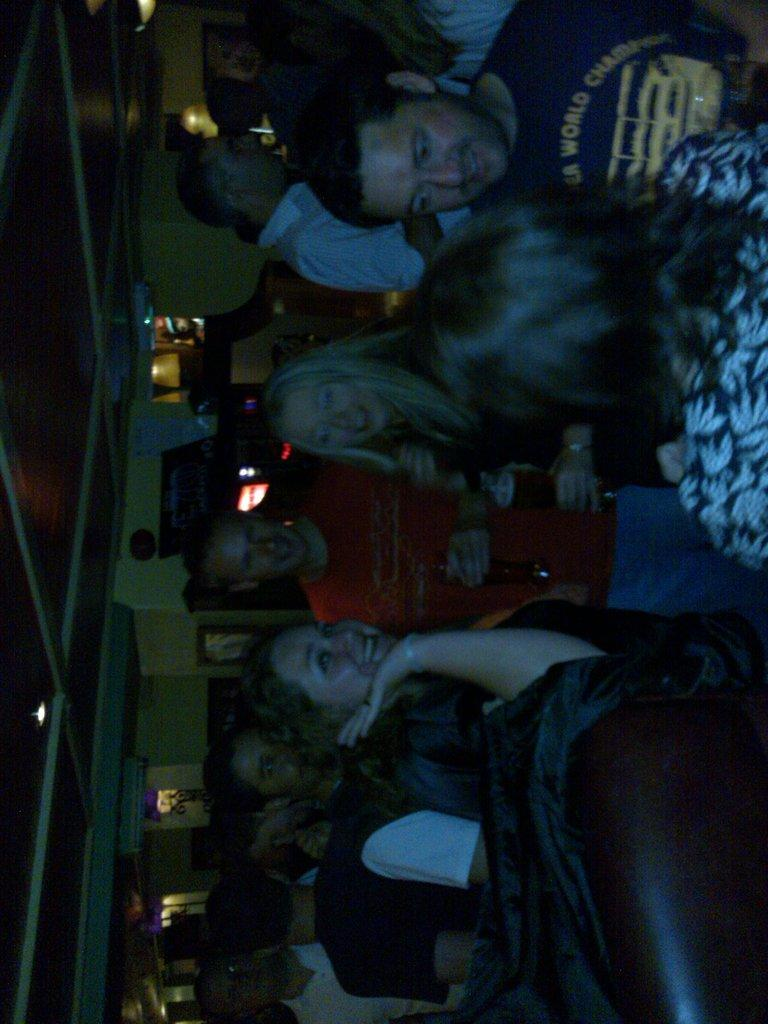How many people are in the image? There are people in the image, but the exact number is not specified. What is the woman holding in the image? The woman is holding a glass in the image. What is the man holding in the image? The man is holding a bottle in the image. What can be seen in the background of the image? There is a wall and lights in the background of the image. Can you describe the lighting in the image? There is a light visible at the top of the image, and there are also lights in the background. How many children are playing with the experience in the image? There is no mention of children or an experience in the image; it features people holding a glass and a bottle, with a wall and lights in the background. 